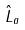<formula> <loc_0><loc_0><loc_500><loc_500>\hat { L } _ { a }</formula> 